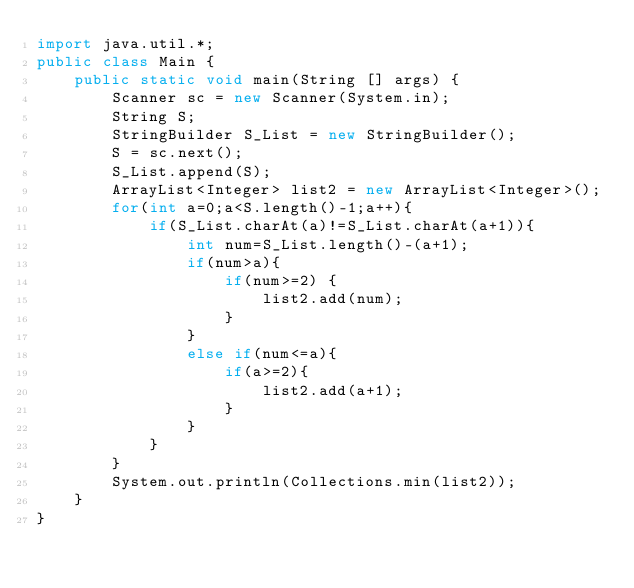<code> <loc_0><loc_0><loc_500><loc_500><_Java_>import java.util.*;
public class Main {
    public static void main(String [] args) {
        Scanner sc = new Scanner(System.in);
        String S;
        StringBuilder S_List = new StringBuilder();
        S = sc.next();
        S_List.append(S);
        ArrayList<Integer> list2 = new ArrayList<Integer>();
        for(int a=0;a<S.length()-1;a++){
            if(S_List.charAt(a)!=S_List.charAt(a+1)){
                int num=S_List.length()-(a+1);
                if(num>a){
                    if(num>=2) {
                        list2.add(num);
                    }
                }
                else if(num<=a){
                    if(a>=2){
                        list2.add(a+1);
                    }
                }
            }
        }
        System.out.println(Collections.min(list2));
    }
}</code> 